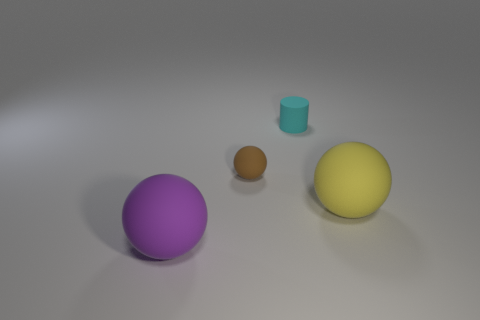Add 1 matte things. How many objects exist? 5 Subtract all cylinders. How many objects are left? 3 Subtract all blue matte cylinders. Subtract all cylinders. How many objects are left? 3 Add 4 large purple things. How many large purple things are left? 5 Add 3 big yellow matte balls. How many big yellow matte balls exist? 4 Subtract 0 blue spheres. How many objects are left? 4 